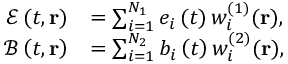Convert formula to latex. <formula><loc_0><loc_0><loc_500><loc_500>\begin{array} { r l } { \mathcal { E } \left ( t , r \right ) } & { = \sum _ { i = 1 } ^ { N _ { 1 } } e _ { i } \left ( t \right ) w _ { i } ^ { ( 1 ) } ( r ) , } \\ { \mathcal { B } \left ( t , r \right ) } & { = \sum _ { i = 1 } ^ { N _ { 2 } } b _ { i } \left ( t \right ) w _ { i } ^ { ( 2 ) } ( r ) , } \end{array}</formula> 